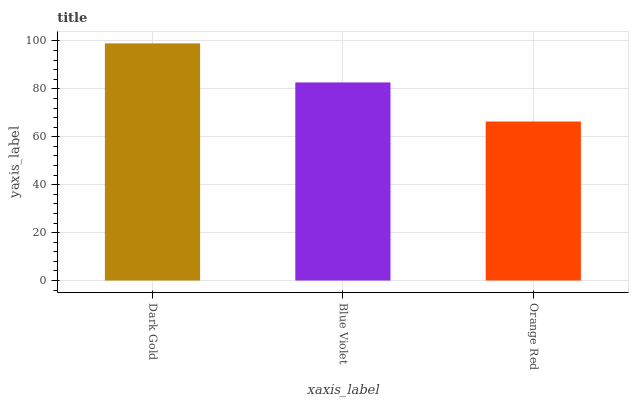Is Orange Red the minimum?
Answer yes or no. Yes. Is Dark Gold the maximum?
Answer yes or no. Yes. Is Blue Violet the minimum?
Answer yes or no. No. Is Blue Violet the maximum?
Answer yes or no. No. Is Dark Gold greater than Blue Violet?
Answer yes or no. Yes. Is Blue Violet less than Dark Gold?
Answer yes or no. Yes. Is Blue Violet greater than Dark Gold?
Answer yes or no. No. Is Dark Gold less than Blue Violet?
Answer yes or no. No. Is Blue Violet the high median?
Answer yes or no. Yes. Is Blue Violet the low median?
Answer yes or no. Yes. Is Orange Red the high median?
Answer yes or no. No. Is Orange Red the low median?
Answer yes or no. No. 